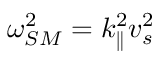Convert formula to latex. <formula><loc_0><loc_0><loc_500><loc_500>\omega _ { S M } ^ { 2 } = k _ { \| } ^ { 2 } v _ { s } ^ { 2 }</formula> 